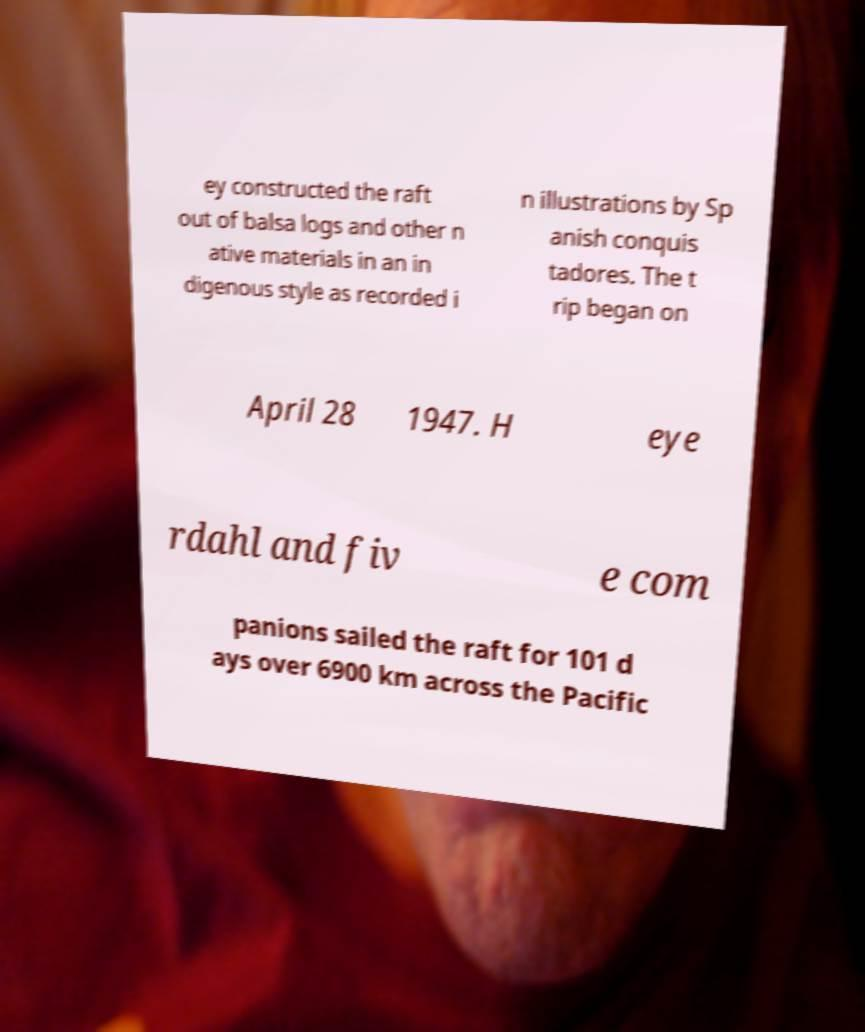Please read and relay the text visible in this image. What does it say? ey constructed the raft out of balsa logs and other n ative materials in an in digenous style as recorded i n illustrations by Sp anish conquis tadores. The t rip began on April 28 1947. H eye rdahl and fiv e com panions sailed the raft for 101 d ays over 6900 km across the Pacific 